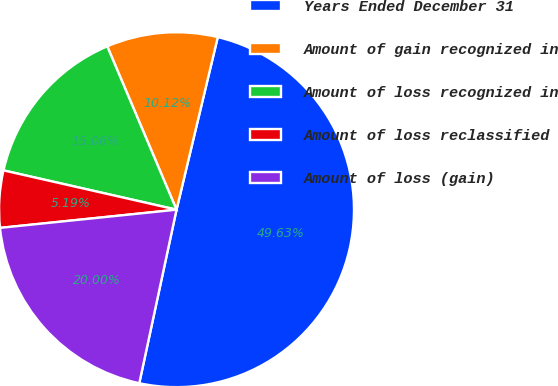<chart> <loc_0><loc_0><loc_500><loc_500><pie_chart><fcel>Years Ended December 31<fcel>Amount of gain recognized in<fcel>Amount of loss recognized in<fcel>Amount of loss reclassified<fcel>Amount of loss (gain)<nl><fcel>49.63%<fcel>10.12%<fcel>15.06%<fcel>5.19%<fcel>20.0%<nl></chart> 